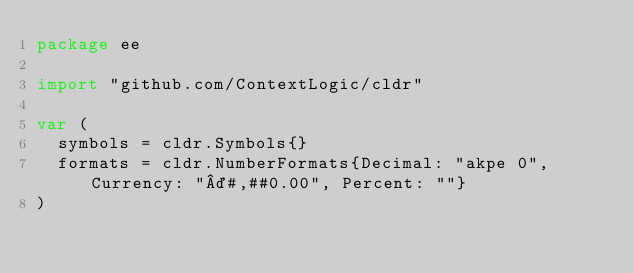<code> <loc_0><loc_0><loc_500><loc_500><_Go_>package ee

import "github.com/ContextLogic/cldr"

var (
	symbols = cldr.Symbols{}
	formats = cldr.NumberFormats{Decimal: "akpe 0", Currency: "¤#,##0.00", Percent: ""}
)
</code> 